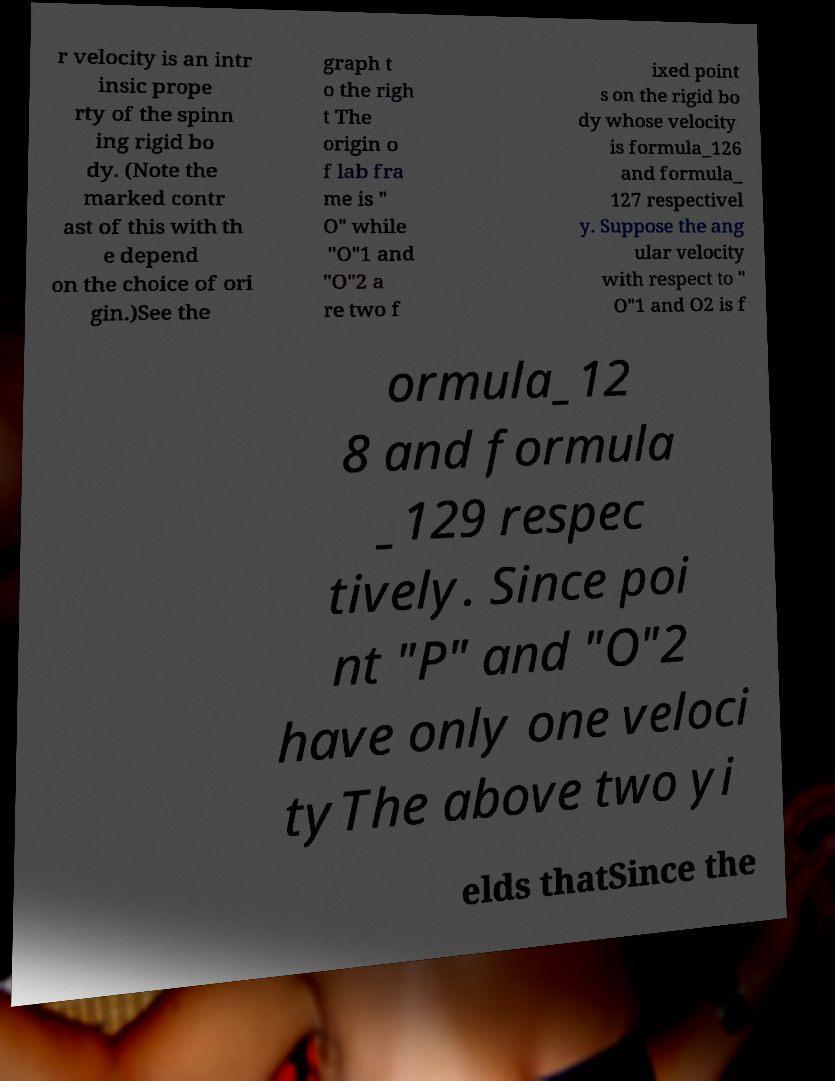I need the written content from this picture converted into text. Can you do that? r velocity is an intr insic prope rty of the spinn ing rigid bo dy. (Note the marked contr ast of this with th e depend on the choice of ori gin.)See the graph t o the righ t The origin o f lab fra me is " O" while "O"1 and "O"2 a re two f ixed point s on the rigid bo dy whose velocity is formula_126 and formula_ 127 respectivel y. Suppose the ang ular velocity with respect to " O"1 and O2 is f ormula_12 8 and formula _129 respec tively. Since poi nt "P" and "O"2 have only one veloci tyThe above two yi elds thatSince the 